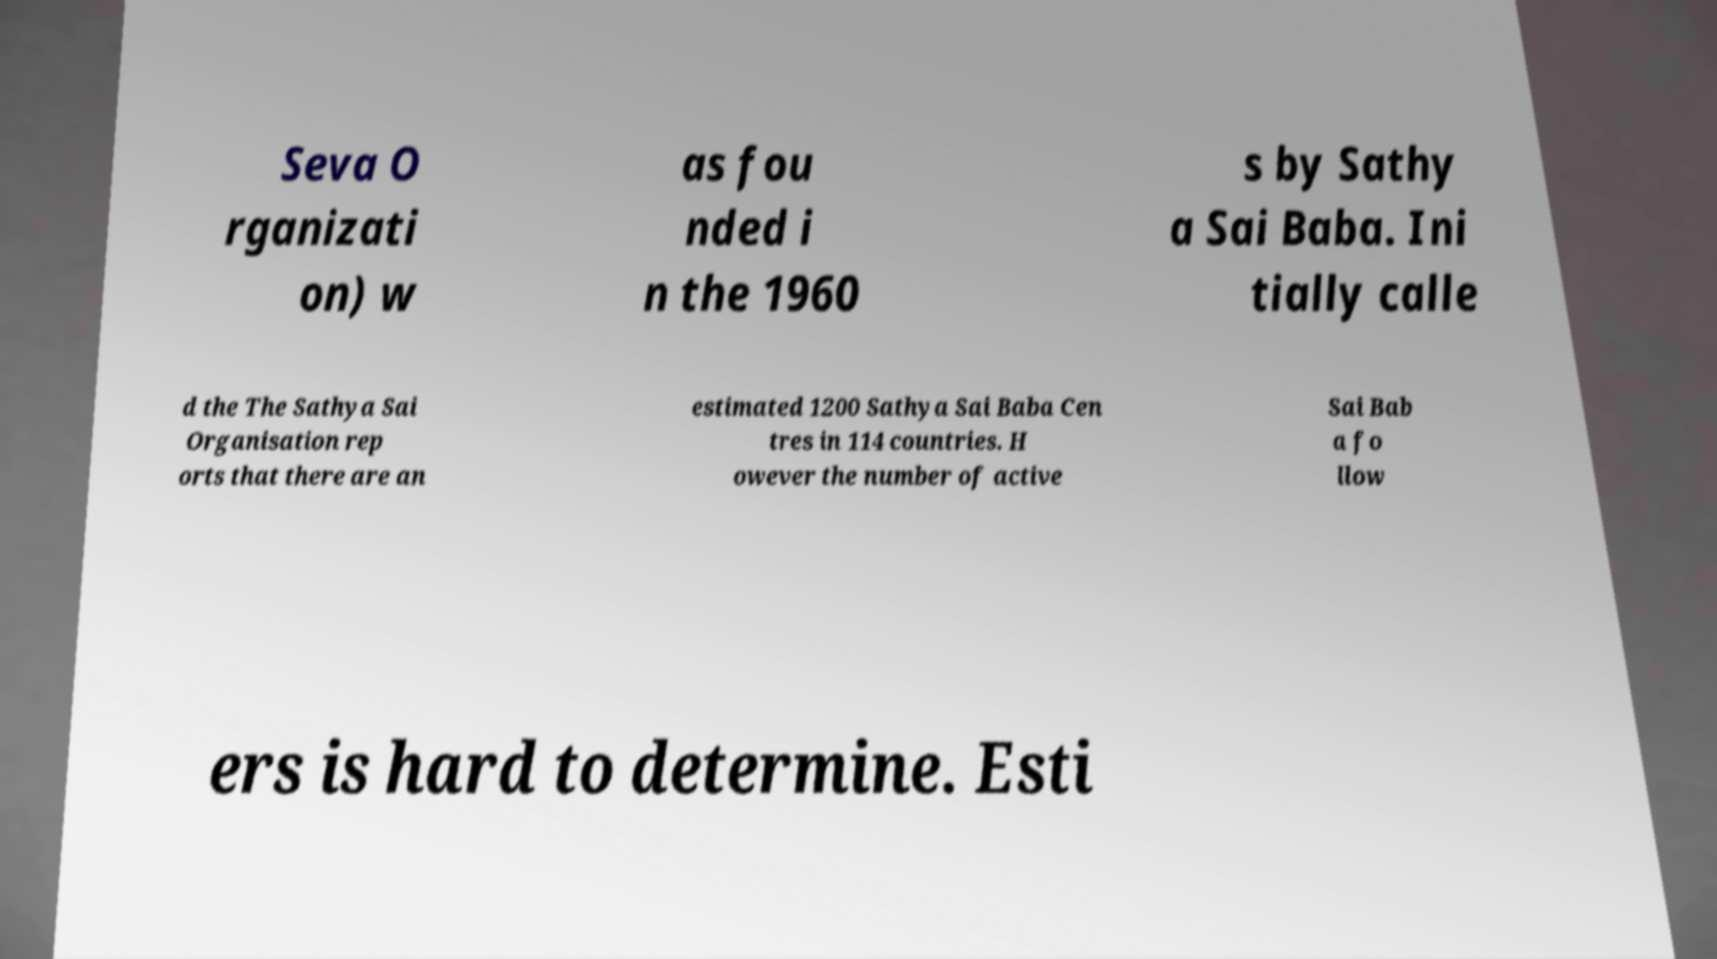There's text embedded in this image that I need extracted. Can you transcribe it verbatim? Seva O rganizati on) w as fou nded i n the 1960 s by Sathy a Sai Baba. Ini tially calle d the The Sathya Sai Organisation rep orts that there are an estimated 1200 Sathya Sai Baba Cen tres in 114 countries. H owever the number of active Sai Bab a fo llow ers is hard to determine. Esti 